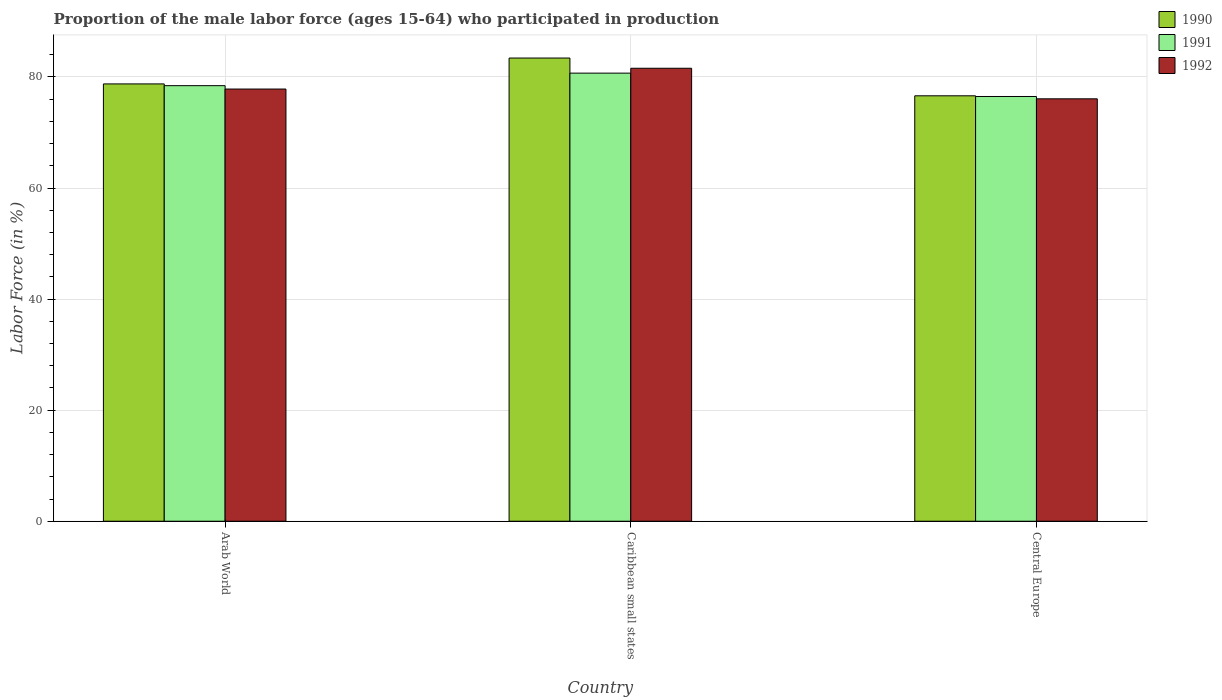How many groups of bars are there?
Provide a succinct answer. 3. How many bars are there on the 2nd tick from the left?
Keep it short and to the point. 3. What is the label of the 1st group of bars from the left?
Provide a succinct answer. Arab World. In how many cases, is the number of bars for a given country not equal to the number of legend labels?
Offer a terse response. 0. What is the proportion of the male labor force who participated in production in 1990 in Arab World?
Your response must be concise. 78.75. Across all countries, what is the maximum proportion of the male labor force who participated in production in 1991?
Offer a terse response. 80.7. Across all countries, what is the minimum proportion of the male labor force who participated in production in 1990?
Ensure brevity in your answer.  76.61. In which country was the proportion of the male labor force who participated in production in 1992 maximum?
Provide a succinct answer. Caribbean small states. In which country was the proportion of the male labor force who participated in production in 1990 minimum?
Give a very brief answer. Central Europe. What is the total proportion of the male labor force who participated in production in 1991 in the graph?
Give a very brief answer. 235.62. What is the difference between the proportion of the male labor force who participated in production in 1992 in Caribbean small states and that in Central Europe?
Your answer should be very brief. 5.5. What is the difference between the proportion of the male labor force who participated in production in 1991 in Arab World and the proportion of the male labor force who participated in production in 1992 in Central Europe?
Offer a terse response. 2.37. What is the average proportion of the male labor force who participated in production in 1991 per country?
Your response must be concise. 78.54. What is the difference between the proportion of the male labor force who participated in production of/in 1990 and proportion of the male labor force who participated in production of/in 1991 in Arab World?
Make the answer very short. 0.31. What is the ratio of the proportion of the male labor force who participated in production in 1991 in Arab World to that in Central Europe?
Ensure brevity in your answer.  1.03. Is the proportion of the male labor force who participated in production in 1992 in Arab World less than that in Central Europe?
Your response must be concise. No. Is the difference between the proportion of the male labor force who participated in production in 1990 in Arab World and Caribbean small states greater than the difference between the proportion of the male labor force who participated in production in 1991 in Arab World and Caribbean small states?
Give a very brief answer. No. What is the difference between the highest and the second highest proportion of the male labor force who participated in production in 1991?
Make the answer very short. 4.21. What is the difference between the highest and the lowest proportion of the male labor force who participated in production in 1991?
Your answer should be compact. 4.21. What does the 1st bar from the right in Arab World represents?
Give a very brief answer. 1992. How many bars are there?
Provide a succinct answer. 9. What is the difference between two consecutive major ticks on the Y-axis?
Offer a terse response. 20. Are the values on the major ticks of Y-axis written in scientific E-notation?
Make the answer very short. No. Does the graph contain any zero values?
Keep it short and to the point. No. Does the graph contain grids?
Keep it short and to the point. Yes. Where does the legend appear in the graph?
Your response must be concise. Top right. How many legend labels are there?
Your response must be concise. 3. What is the title of the graph?
Ensure brevity in your answer.  Proportion of the male labor force (ages 15-64) who participated in production. Does "2012" appear as one of the legend labels in the graph?
Make the answer very short. No. What is the Labor Force (in %) in 1990 in Arab World?
Make the answer very short. 78.75. What is the Labor Force (in %) in 1991 in Arab World?
Offer a very short reply. 78.44. What is the Labor Force (in %) in 1992 in Arab World?
Provide a short and direct response. 77.83. What is the Labor Force (in %) of 1990 in Caribbean small states?
Give a very brief answer. 83.41. What is the Labor Force (in %) of 1991 in Caribbean small states?
Ensure brevity in your answer.  80.7. What is the Labor Force (in %) of 1992 in Caribbean small states?
Provide a succinct answer. 81.57. What is the Labor Force (in %) in 1990 in Central Europe?
Give a very brief answer. 76.61. What is the Labor Force (in %) in 1991 in Central Europe?
Provide a succinct answer. 76.49. What is the Labor Force (in %) of 1992 in Central Europe?
Provide a succinct answer. 76.07. Across all countries, what is the maximum Labor Force (in %) of 1990?
Make the answer very short. 83.41. Across all countries, what is the maximum Labor Force (in %) in 1991?
Keep it short and to the point. 80.7. Across all countries, what is the maximum Labor Force (in %) in 1992?
Provide a succinct answer. 81.57. Across all countries, what is the minimum Labor Force (in %) of 1990?
Provide a short and direct response. 76.61. Across all countries, what is the minimum Labor Force (in %) of 1991?
Give a very brief answer. 76.49. Across all countries, what is the minimum Labor Force (in %) of 1992?
Ensure brevity in your answer.  76.07. What is the total Labor Force (in %) in 1990 in the graph?
Your answer should be compact. 238.78. What is the total Labor Force (in %) of 1991 in the graph?
Provide a succinct answer. 235.62. What is the total Labor Force (in %) in 1992 in the graph?
Offer a very short reply. 235.47. What is the difference between the Labor Force (in %) of 1990 in Arab World and that in Caribbean small states?
Offer a terse response. -4.66. What is the difference between the Labor Force (in %) in 1991 in Arab World and that in Caribbean small states?
Your answer should be very brief. -2.26. What is the difference between the Labor Force (in %) of 1992 in Arab World and that in Caribbean small states?
Your response must be concise. -3.74. What is the difference between the Labor Force (in %) in 1990 in Arab World and that in Central Europe?
Offer a very short reply. 2.14. What is the difference between the Labor Force (in %) of 1991 in Arab World and that in Central Europe?
Your answer should be compact. 1.95. What is the difference between the Labor Force (in %) in 1992 in Arab World and that in Central Europe?
Offer a very short reply. 1.76. What is the difference between the Labor Force (in %) of 1990 in Caribbean small states and that in Central Europe?
Your answer should be very brief. 6.8. What is the difference between the Labor Force (in %) in 1991 in Caribbean small states and that in Central Europe?
Provide a succinct answer. 4.21. What is the difference between the Labor Force (in %) of 1992 in Caribbean small states and that in Central Europe?
Your answer should be very brief. 5.5. What is the difference between the Labor Force (in %) of 1990 in Arab World and the Labor Force (in %) of 1991 in Caribbean small states?
Provide a succinct answer. -1.94. What is the difference between the Labor Force (in %) of 1990 in Arab World and the Labor Force (in %) of 1992 in Caribbean small states?
Provide a short and direct response. -2.82. What is the difference between the Labor Force (in %) of 1991 in Arab World and the Labor Force (in %) of 1992 in Caribbean small states?
Your response must be concise. -3.13. What is the difference between the Labor Force (in %) in 1990 in Arab World and the Labor Force (in %) in 1991 in Central Europe?
Offer a very short reply. 2.26. What is the difference between the Labor Force (in %) in 1990 in Arab World and the Labor Force (in %) in 1992 in Central Europe?
Ensure brevity in your answer.  2.68. What is the difference between the Labor Force (in %) in 1991 in Arab World and the Labor Force (in %) in 1992 in Central Europe?
Offer a terse response. 2.37. What is the difference between the Labor Force (in %) of 1990 in Caribbean small states and the Labor Force (in %) of 1991 in Central Europe?
Make the answer very short. 6.92. What is the difference between the Labor Force (in %) of 1990 in Caribbean small states and the Labor Force (in %) of 1992 in Central Europe?
Your answer should be compact. 7.34. What is the difference between the Labor Force (in %) of 1991 in Caribbean small states and the Labor Force (in %) of 1992 in Central Europe?
Offer a very short reply. 4.63. What is the average Labor Force (in %) of 1990 per country?
Your answer should be very brief. 79.59. What is the average Labor Force (in %) of 1991 per country?
Offer a terse response. 78.54. What is the average Labor Force (in %) in 1992 per country?
Your answer should be very brief. 78.49. What is the difference between the Labor Force (in %) of 1990 and Labor Force (in %) of 1991 in Arab World?
Make the answer very short. 0.31. What is the difference between the Labor Force (in %) in 1990 and Labor Force (in %) in 1992 in Arab World?
Offer a terse response. 0.92. What is the difference between the Labor Force (in %) in 1991 and Labor Force (in %) in 1992 in Arab World?
Your response must be concise. 0.61. What is the difference between the Labor Force (in %) in 1990 and Labor Force (in %) in 1991 in Caribbean small states?
Your answer should be very brief. 2.72. What is the difference between the Labor Force (in %) of 1990 and Labor Force (in %) of 1992 in Caribbean small states?
Provide a short and direct response. 1.84. What is the difference between the Labor Force (in %) in 1991 and Labor Force (in %) in 1992 in Caribbean small states?
Your response must be concise. -0.88. What is the difference between the Labor Force (in %) in 1990 and Labor Force (in %) in 1991 in Central Europe?
Your answer should be compact. 0.12. What is the difference between the Labor Force (in %) in 1990 and Labor Force (in %) in 1992 in Central Europe?
Provide a short and direct response. 0.54. What is the difference between the Labor Force (in %) of 1991 and Labor Force (in %) of 1992 in Central Europe?
Make the answer very short. 0.42. What is the ratio of the Labor Force (in %) of 1990 in Arab World to that in Caribbean small states?
Provide a succinct answer. 0.94. What is the ratio of the Labor Force (in %) in 1992 in Arab World to that in Caribbean small states?
Provide a succinct answer. 0.95. What is the ratio of the Labor Force (in %) in 1990 in Arab World to that in Central Europe?
Give a very brief answer. 1.03. What is the ratio of the Labor Force (in %) of 1991 in Arab World to that in Central Europe?
Your answer should be compact. 1.03. What is the ratio of the Labor Force (in %) in 1992 in Arab World to that in Central Europe?
Ensure brevity in your answer.  1.02. What is the ratio of the Labor Force (in %) in 1990 in Caribbean small states to that in Central Europe?
Keep it short and to the point. 1.09. What is the ratio of the Labor Force (in %) of 1991 in Caribbean small states to that in Central Europe?
Make the answer very short. 1.05. What is the ratio of the Labor Force (in %) in 1992 in Caribbean small states to that in Central Europe?
Your answer should be very brief. 1.07. What is the difference between the highest and the second highest Labor Force (in %) in 1990?
Give a very brief answer. 4.66. What is the difference between the highest and the second highest Labor Force (in %) in 1991?
Ensure brevity in your answer.  2.26. What is the difference between the highest and the second highest Labor Force (in %) of 1992?
Your answer should be compact. 3.74. What is the difference between the highest and the lowest Labor Force (in %) in 1990?
Provide a succinct answer. 6.8. What is the difference between the highest and the lowest Labor Force (in %) of 1991?
Provide a short and direct response. 4.21. What is the difference between the highest and the lowest Labor Force (in %) in 1992?
Your response must be concise. 5.5. 